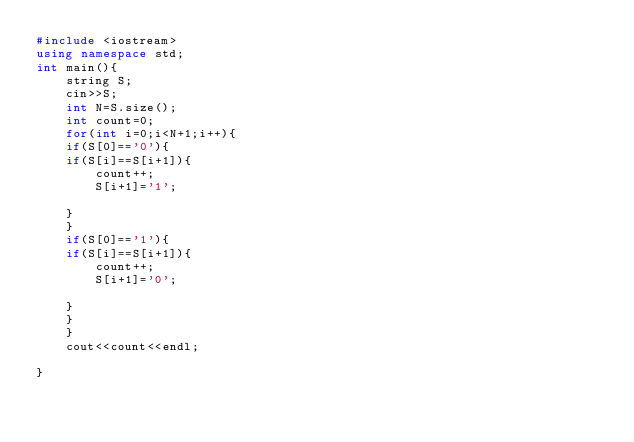Convert code to text. <code><loc_0><loc_0><loc_500><loc_500><_C++_>#include <iostream>
using namespace std;
int main(){
    string S;
    cin>>S;
    int N=S.size();
    int count=0;
    for(int i=0;i<N+1;i++){
    if(S[0]=='0'){
    if(S[i]==S[i+1]){
        count++;
        S[i+1]='1';
        
    }
    }
    if(S[0]=='1'){
    if(S[i]==S[i+1]){
        count++;
        S[i+1]='0';
        
    }
    }
    }
    cout<<count<<endl;
    
}</code> 